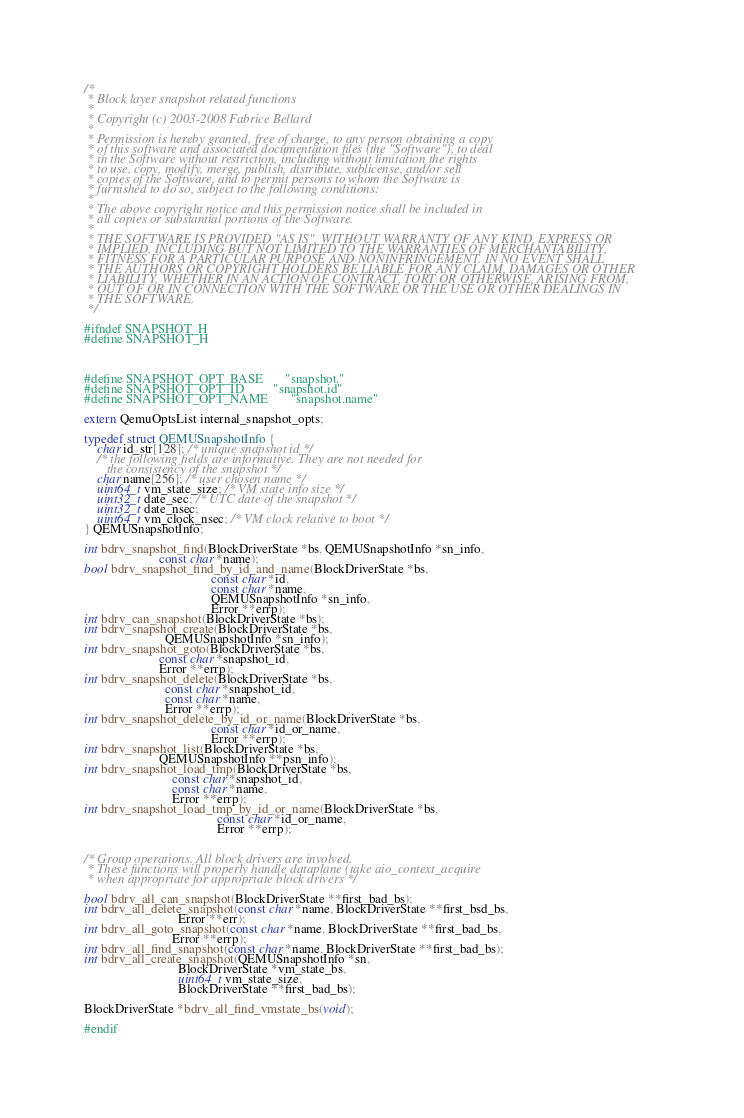Convert code to text. <code><loc_0><loc_0><loc_500><loc_500><_C_>/*
 * Block layer snapshot related functions
 *
 * Copyright (c) 2003-2008 Fabrice Bellard
 *
 * Permission is hereby granted, free of charge, to any person obtaining a copy
 * of this software and associated documentation files (the "Software"), to deal
 * in the Software without restriction, including without limitation the rights
 * to use, copy, modify, merge, publish, distribute, sublicense, and/or sell
 * copies of the Software, and to permit persons to whom the Software is
 * furnished to do so, subject to the following conditions:
 *
 * The above copyright notice and this permission notice shall be included in
 * all copies or substantial portions of the Software.
 *
 * THE SOFTWARE IS PROVIDED "AS IS", WITHOUT WARRANTY OF ANY KIND, EXPRESS OR
 * IMPLIED, INCLUDING BUT NOT LIMITED TO THE WARRANTIES OF MERCHANTABILITY,
 * FITNESS FOR A PARTICULAR PURPOSE AND NONINFRINGEMENT. IN NO EVENT SHALL
 * THE AUTHORS OR COPYRIGHT HOLDERS BE LIABLE FOR ANY CLAIM, DAMAGES OR OTHER
 * LIABILITY, WHETHER IN AN ACTION OF CONTRACT, TORT OR OTHERWISE, ARISING FROM,
 * OUT OF OR IN CONNECTION WITH THE SOFTWARE OR THE USE OR OTHER DEALINGS IN
 * THE SOFTWARE.
 */

#ifndef SNAPSHOT_H
#define SNAPSHOT_H



#define SNAPSHOT_OPT_BASE       "snapshot."
#define SNAPSHOT_OPT_ID         "snapshot.id"
#define SNAPSHOT_OPT_NAME       "snapshot.name"

extern QemuOptsList internal_snapshot_opts;

typedef struct QEMUSnapshotInfo {
    char id_str[128]; /* unique snapshot id */
    /* the following fields are informative. They are not needed for
       the consistency of the snapshot */
    char name[256]; /* user chosen name */
    uint64_t vm_state_size; /* VM state info size */
    uint32_t date_sec; /* UTC date of the snapshot */
    uint32_t date_nsec;
    uint64_t vm_clock_nsec; /* VM clock relative to boot */
} QEMUSnapshotInfo;

int bdrv_snapshot_find(BlockDriverState *bs, QEMUSnapshotInfo *sn_info,
                       const char *name);
bool bdrv_snapshot_find_by_id_and_name(BlockDriverState *bs,
                                       const char *id,
                                       const char *name,
                                       QEMUSnapshotInfo *sn_info,
                                       Error **errp);
int bdrv_can_snapshot(BlockDriverState *bs);
int bdrv_snapshot_create(BlockDriverState *bs,
                         QEMUSnapshotInfo *sn_info);
int bdrv_snapshot_goto(BlockDriverState *bs,
                       const char *snapshot_id,
                       Error **errp);
int bdrv_snapshot_delete(BlockDriverState *bs,
                         const char *snapshot_id,
                         const char *name,
                         Error **errp);
int bdrv_snapshot_delete_by_id_or_name(BlockDriverState *bs,
                                       const char *id_or_name,
                                       Error **errp);
int bdrv_snapshot_list(BlockDriverState *bs,
                       QEMUSnapshotInfo **psn_info);
int bdrv_snapshot_load_tmp(BlockDriverState *bs,
                           const char *snapshot_id,
                           const char *name,
                           Error **errp);
int bdrv_snapshot_load_tmp_by_id_or_name(BlockDriverState *bs,
                                         const char *id_or_name,
                                         Error **errp);


/* Group operations. All block drivers are involved.
 * These functions will properly handle dataplane (take aio_context_acquire
 * when appropriate for appropriate block drivers */

bool bdrv_all_can_snapshot(BlockDriverState **first_bad_bs);
int bdrv_all_delete_snapshot(const char *name, BlockDriverState **first_bsd_bs,
                             Error **err);
int bdrv_all_goto_snapshot(const char *name, BlockDriverState **first_bad_bs,
                           Error **errp);
int bdrv_all_find_snapshot(const char *name, BlockDriverState **first_bad_bs);
int bdrv_all_create_snapshot(QEMUSnapshotInfo *sn,
                             BlockDriverState *vm_state_bs,
                             uint64_t vm_state_size,
                             BlockDriverState **first_bad_bs);

BlockDriverState *bdrv_all_find_vmstate_bs(void);

#endif
</code> 